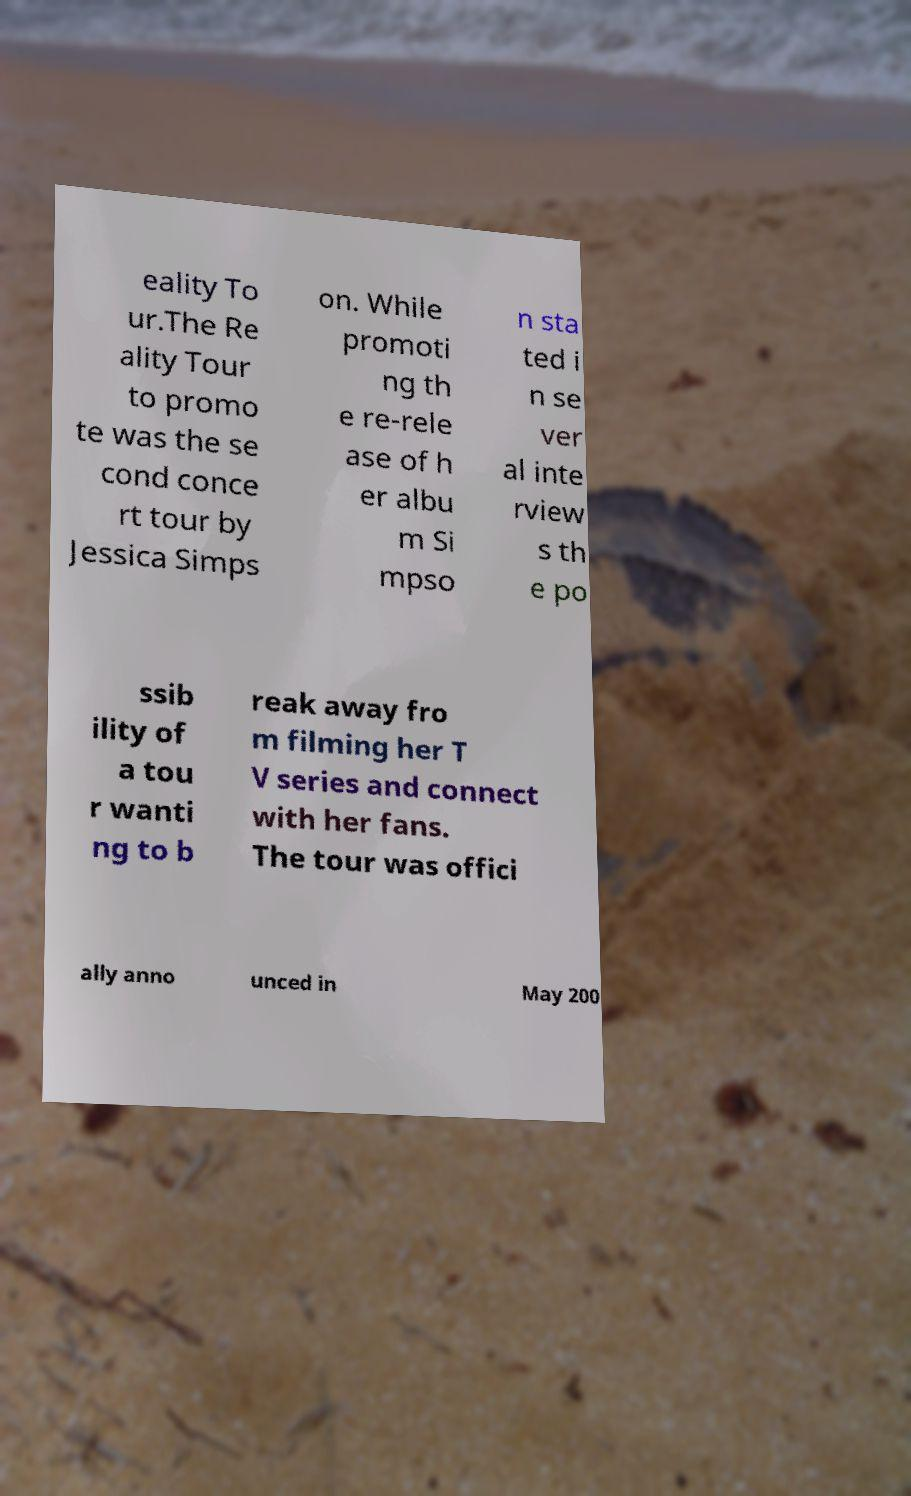Can you read and provide the text displayed in the image?This photo seems to have some interesting text. Can you extract and type it out for me? eality To ur.The Re ality Tour to promo te was the se cond conce rt tour by Jessica Simps on. While promoti ng th e re-rele ase of h er albu m Si mpso n sta ted i n se ver al inte rview s th e po ssib ility of a tou r wanti ng to b reak away fro m filming her T V series and connect with her fans. The tour was offici ally anno unced in May 200 